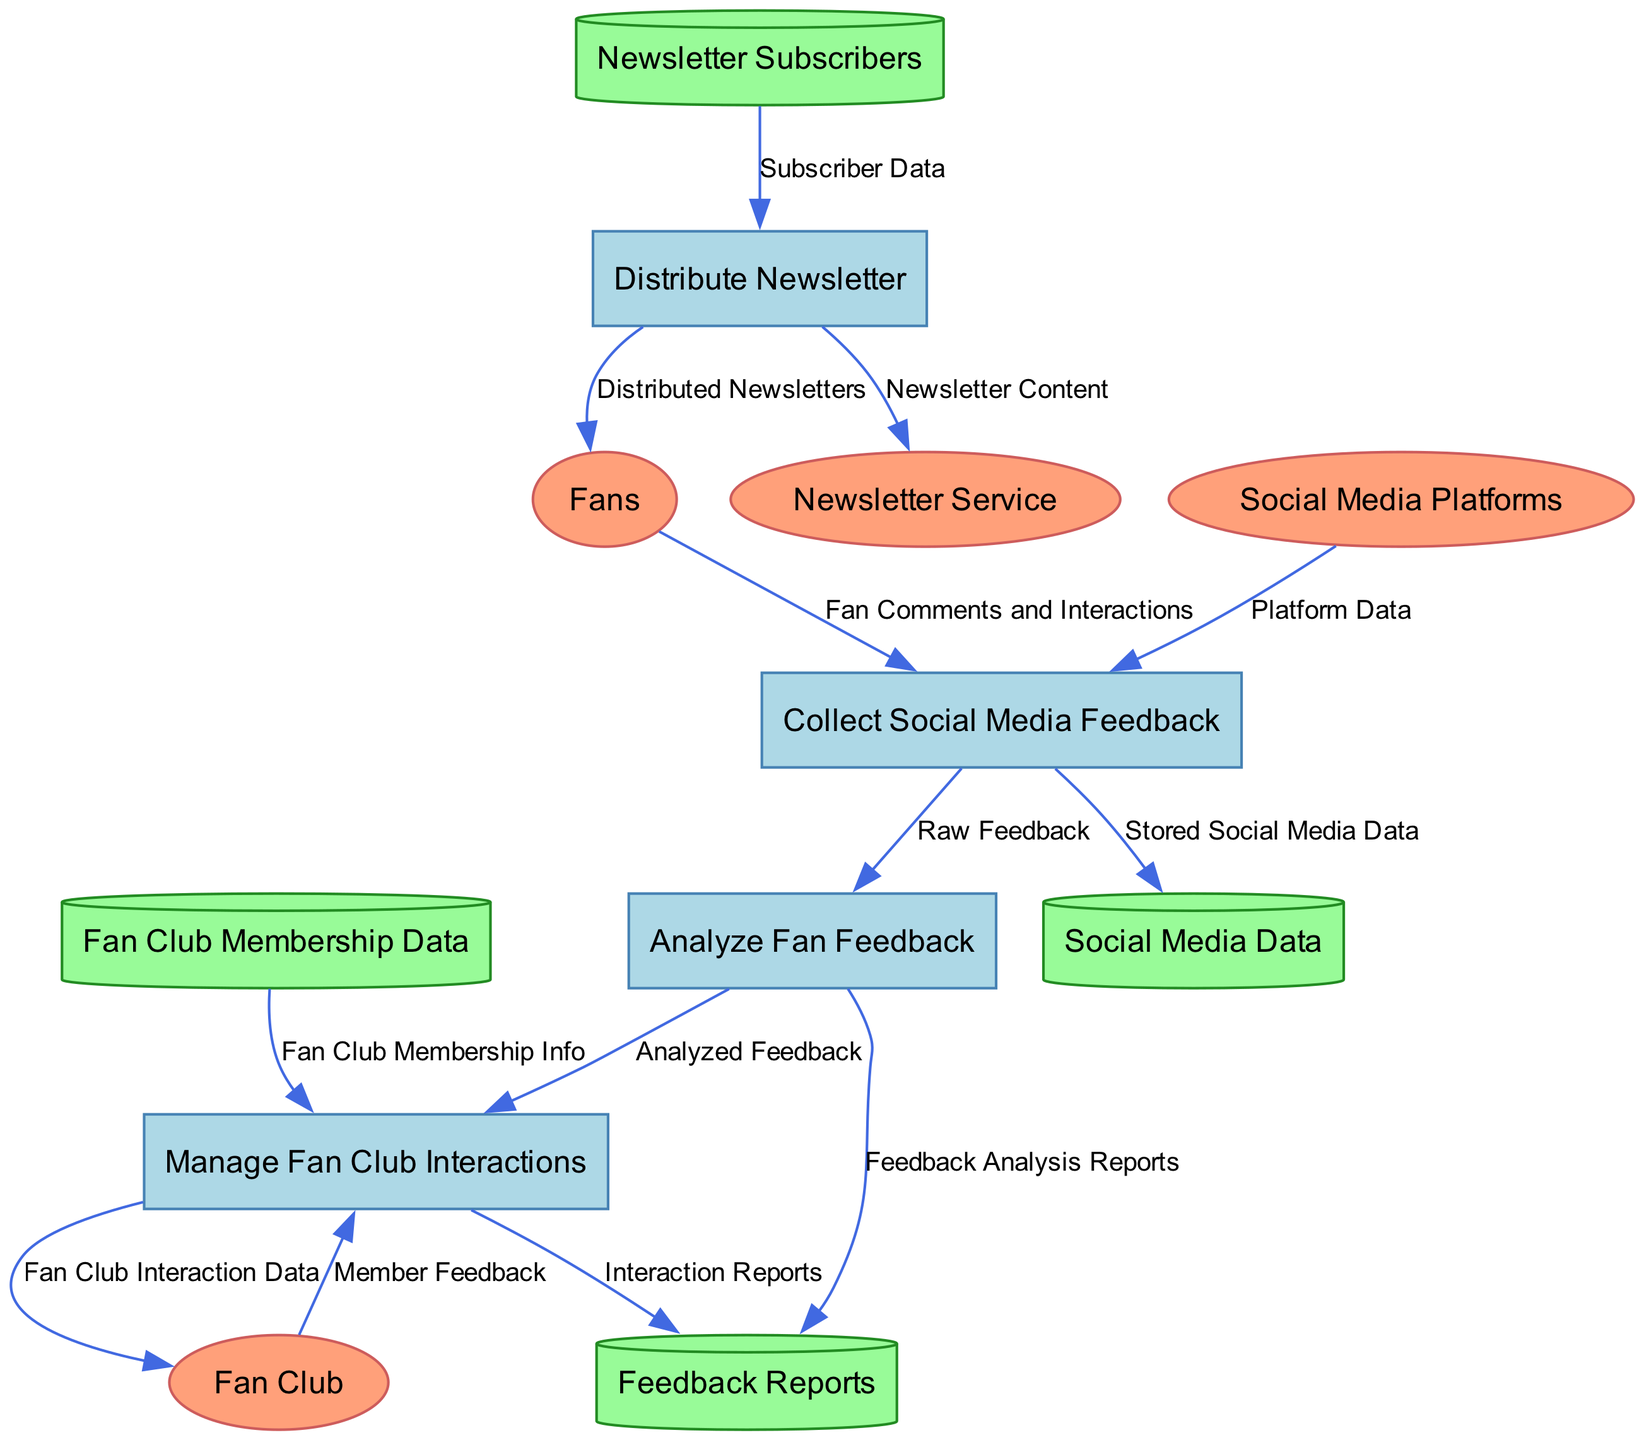What is the first process in the diagram? The diagram shows the processes starting with "Collect Social Media Feedback" which is labeled as process 1.
Answer: Collect Social Media Feedback How many data stores are present? The diagram lists four data stores: Social Media Data, Newsletter Subscribers, Fan Club Membership Data, and Feedback Reports. This can be counted directly from the data stores section.
Answer: 4 Who provides "Member Feedback"? The "Member Feedback" comes from the external entity labeled as "Fan Club," which is indicated as the source to process the fan club interactions.
Answer: Fan Club What is stored as "Stored Social Media Data"? The stored social media data is the outcome of the first process "Collect Social Media Feedback," which takes in fan comments and interactions, as shown in the data flow connection from the process to the data store.
Answer: Stored Social Media Data Which process receives "Platform Data"? The process "Collect Social Media Feedback" receives "Platform Data" from the external entity "Social Media Platforms," indicated by the directed data flow leading towards it.
Answer: Collect Social Media Feedback What is one of the outputs of the process "Analyze Fan Feedback"? One of the outputs is "Feedback Analysis Reports," which is generated from the analyzed feedback and stored in the data store labeled "Feedback Reports." This is shown in the flow leading to that data store.
Answer: Feedback Analysis Reports How many external entities are involved in the diagram? The diagram includes four external entities: Fans, Social Media Platforms, Newsletter Service, and Fan Club. This can be confirmed by counting the entities listed in the external entities section.
Answer: 4 Which process distributes content to fans? The process "Distribute Newsletter" is responsible for sending out content to fans, indicated by its flow leading to the "Distributed Newsletters" outcome.
Answer: Distribute Newsletter What type of feedback does the process "Manage Fan Club Interactions" analyze? The process "Manage Fan Club Interactions" analyzes "Member Feedback," which comes from the fan club external entity and flows into that process, indicating the type of feedback being managed.
Answer: Member Feedback 